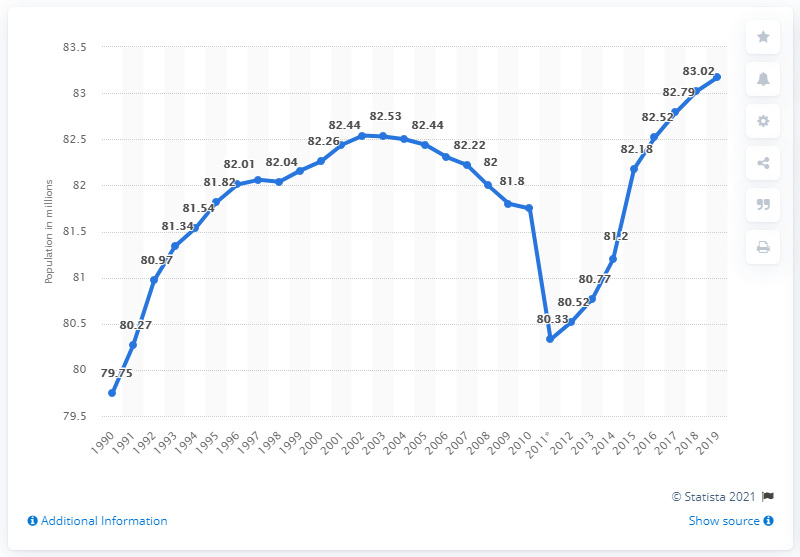List a handful of essential elements in this visual. As of December 31, 2019, the population of Germany was 83.17 million. 